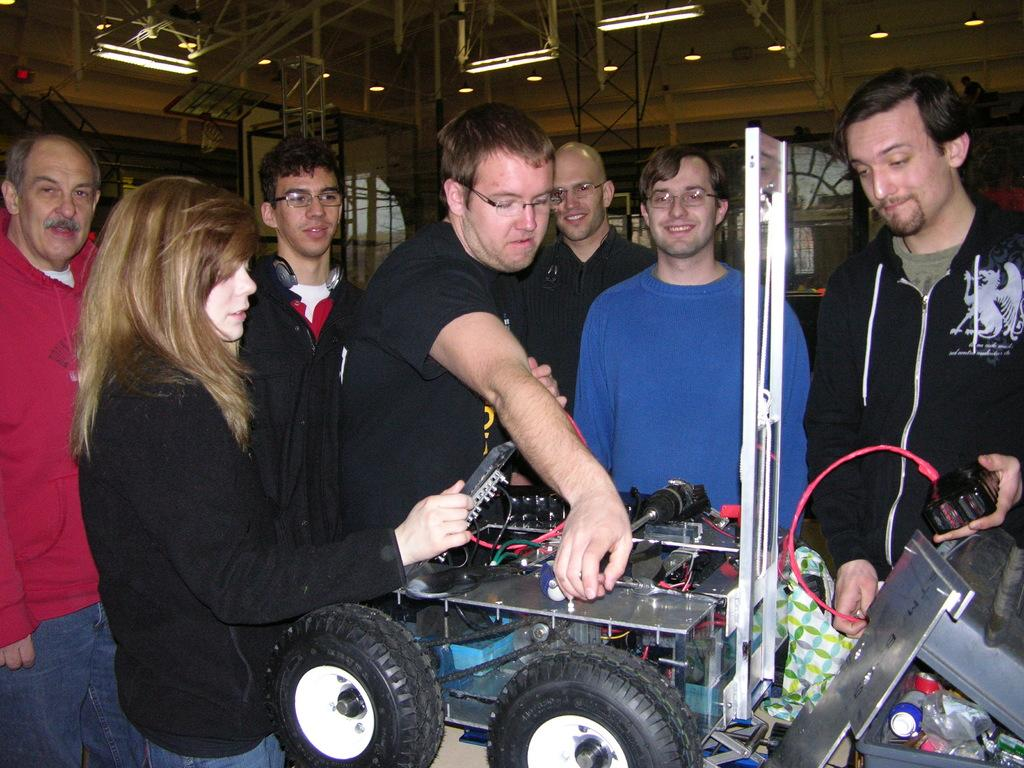How many people are in the image? There are people in the image, but the exact number is not specified. What are the people doing in the image? The people are standing in front of a table. What can be seen on the table in the image? There is an electronic gadget on the table. What is visible on the roof in the image? There are lights on the roof in the image. What type of temper do the rabbits in the image have? There are no rabbits present in the image. What industry is represented by the electronic gadget on the table? The facts do not provide enough information to determine the industry associated with the electronic gadget. 